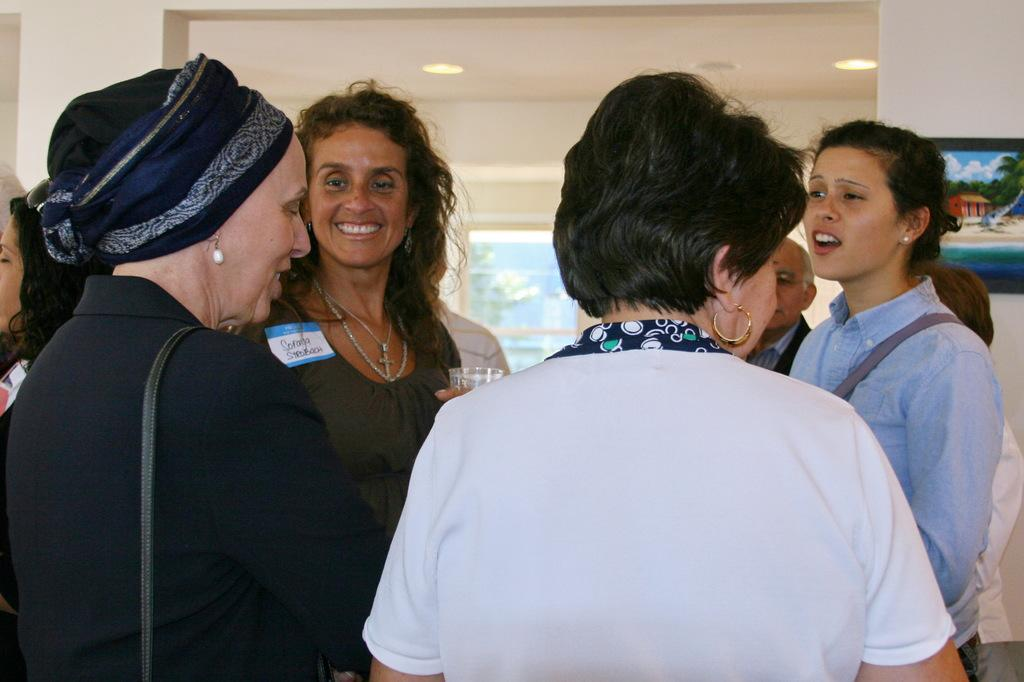How many people are in the image? There is a group of people standing in the image. What is one person holding in the image? There is a person holding a glass in the image. What can be seen on the wall in the background of the image? There is a frame attached to the wall in the background of the image. What is visible in the background of the image that might provide light? There are lights visible in the background of the image. What type of thread is being used to sew the calculator in the image? There is no calculator or thread present in the image. 